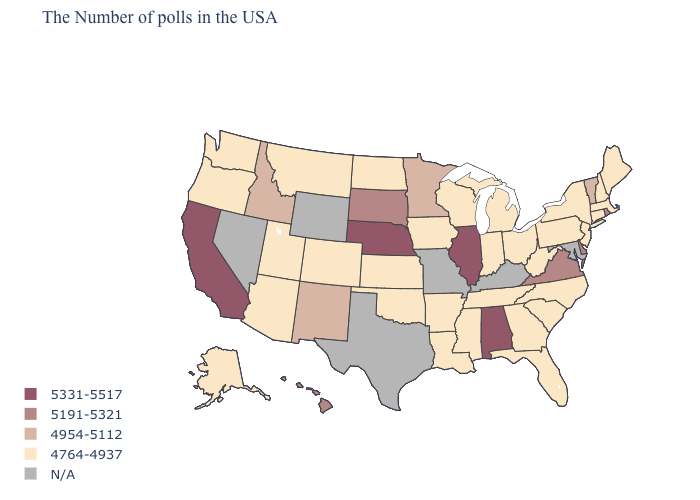Is the legend a continuous bar?
Write a very short answer. No. Which states have the lowest value in the USA?
Answer briefly. Maine, Massachusetts, New Hampshire, Connecticut, New York, New Jersey, Pennsylvania, North Carolina, South Carolina, West Virginia, Ohio, Florida, Georgia, Michigan, Indiana, Tennessee, Wisconsin, Mississippi, Louisiana, Arkansas, Iowa, Kansas, Oklahoma, North Dakota, Colorado, Utah, Montana, Arizona, Washington, Oregon, Alaska. What is the value of Michigan?
Quick response, please. 4764-4937. Does the map have missing data?
Quick response, please. Yes. What is the value of Iowa?
Be succinct. 4764-4937. Which states have the lowest value in the West?
Be succinct. Colorado, Utah, Montana, Arizona, Washington, Oregon, Alaska. What is the value of Louisiana?
Answer briefly. 4764-4937. How many symbols are there in the legend?
Short answer required. 5. What is the value of Ohio?
Write a very short answer. 4764-4937. What is the value of Washington?
Keep it brief. 4764-4937. What is the value of New Jersey?
Write a very short answer. 4764-4937. What is the value of Wisconsin?
Short answer required. 4764-4937. Name the states that have a value in the range 5331-5517?
Short answer required. Alabama, Illinois, Nebraska, California. Name the states that have a value in the range 4954-5112?
Write a very short answer. Vermont, Minnesota, New Mexico, Idaho. 